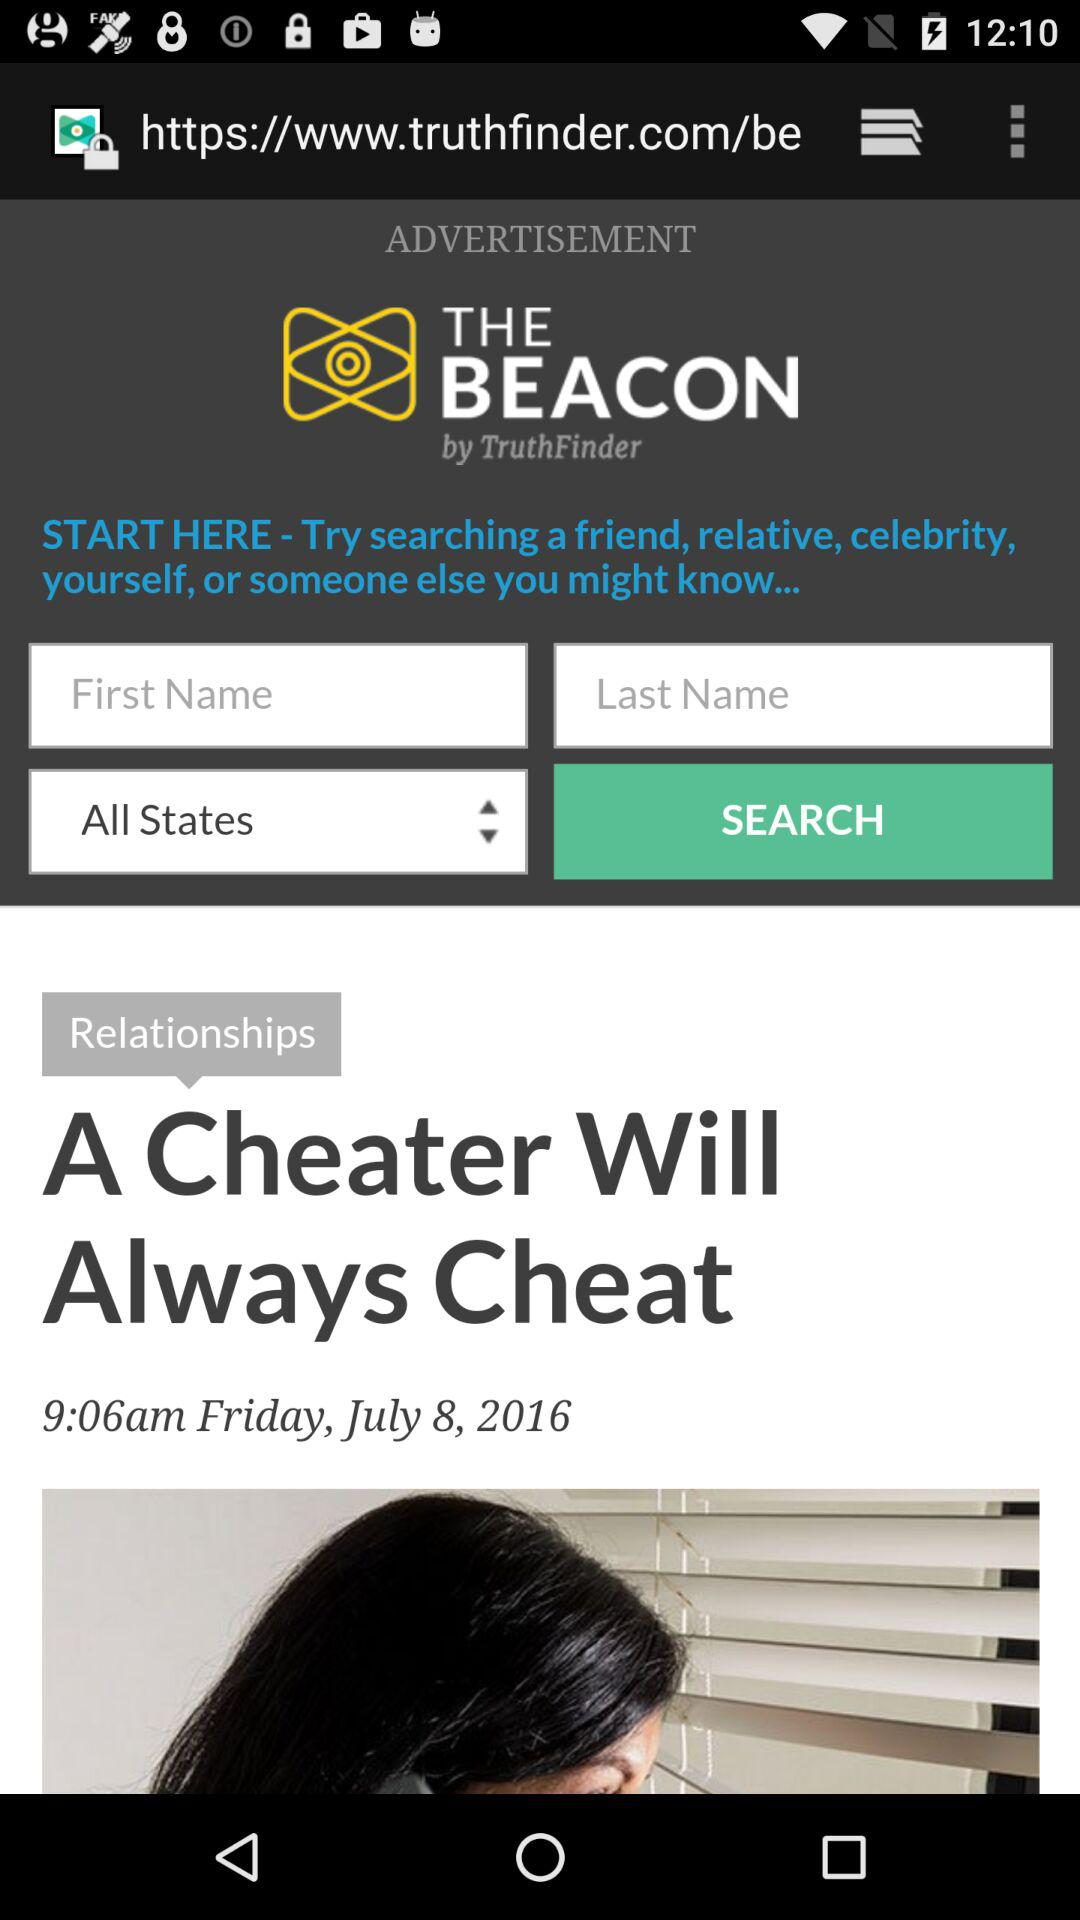What is the date and time? The date and time are Friday, July 8, 2016 and 9:06 AM, respectively. 